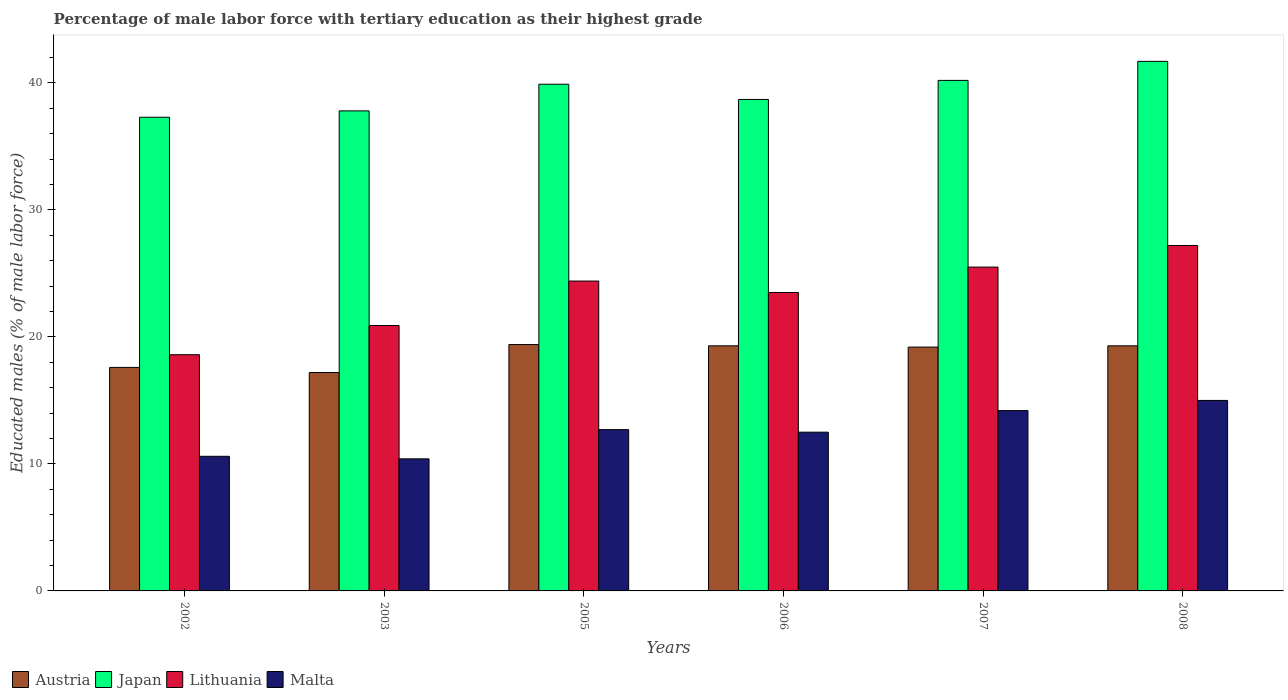How many different coloured bars are there?
Keep it short and to the point. 4. How many groups of bars are there?
Your response must be concise. 6. How many bars are there on the 3rd tick from the right?
Keep it short and to the point. 4. What is the label of the 6th group of bars from the left?
Make the answer very short. 2008. What is the percentage of male labor force with tertiary education in Japan in 2002?
Your answer should be compact. 37.3. Across all years, what is the maximum percentage of male labor force with tertiary education in Japan?
Offer a terse response. 41.7. Across all years, what is the minimum percentage of male labor force with tertiary education in Austria?
Your response must be concise. 17.2. In which year was the percentage of male labor force with tertiary education in Lithuania maximum?
Offer a very short reply. 2008. In which year was the percentage of male labor force with tertiary education in Japan minimum?
Your answer should be compact. 2002. What is the total percentage of male labor force with tertiary education in Austria in the graph?
Offer a terse response. 112. What is the difference between the percentage of male labor force with tertiary education in Lithuania in 2003 and that in 2008?
Your response must be concise. -6.3. What is the difference between the percentage of male labor force with tertiary education in Malta in 2008 and the percentage of male labor force with tertiary education in Austria in 2005?
Give a very brief answer. -4.4. What is the average percentage of male labor force with tertiary education in Malta per year?
Offer a terse response. 12.57. In the year 2003, what is the difference between the percentage of male labor force with tertiary education in Japan and percentage of male labor force with tertiary education in Malta?
Keep it short and to the point. 27.4. In how many years, is the percentage of male labor force with tertiary education in Malta greater than 32 %?
Offer a terse response. 0. What is the ratio of the percentage of male labor force with tertiary education in Lithuania in 2003 to that in 2007?
Keep it short and to the point. 0.82. Is the percentage of male labor force with tertiary education in Austria in 2005 less than that in 2007?
Keep it short and to the point. No. Is the difference between the percentage of male labor force with tertiary education in Japan in 2002 and 2008 greater than the difference between the percentage of male labor force with tertiary education in Malta in 2002 and 2008?
Your answer should be compact. No. What is the difference between the highest and the second highest percentage of male labor force with tertiary education in Austria?
Your answer should be compact. 0.1. What is the difference between the highest and the lowest percentage of male labor force with tertiary education in Japan?
Your answer should be compact. 4.4. In how many years, is the percentage of male labor force with tertiary education in Malta greater than the average percentage of male labor force with tertiary education in Malta taken over all years?
Make the answer very short. 3. Is the sum of the percentage of male labor force with tertiary education in Malta in 2002 and 2007 greater than the maximum percentage of male labor force with tertiary education in Japan across all years?
Give a very brief answer. No. What does the 3rd bar from the left in 2002 represents?
Offer a very short reply. Lithuania. Is it the case that in every year, the sum of the percentage of male labor force with tertiary education in Austria and percentage of male labor force with tertiary education in Japan is greater than the percentage of male labor force with tertiary education in Malta?
Give a very brief answer. Yes. Are the values on the major ticks of Y-axis written in scientific E-notation?
Your response must be concise. No. Does the graph contain any zero values?
Provide a short and direct response. No. What is the title of the graph?
Ensure brevity in your answer.  Percentage of male labor force with tertiary education as their highest grade. What is the label or title of the X-axis?
Offer a very short reply. Years. What is the label or title of the Y-axis?
Ensure brevity in your answer.  Educated males (% of male labor force). What is the Educated males (% of male labor force) in Austria in 2002?
Your response must be concise. 17.6. What is the Educated males (% of male labor force) in Japan in 2002?
Offer a very short reply. 37.3. What is the Educated males (% of male labor force) in Lithuania in 2002?
Ensure brevity in your answer.  18.6. What is the Educated males (% of male labor force) in Malta in 2002?
Your answer should be compact. 10.6. What is the Educated males (% of male labor force) of Austria in 2003?
Your answer should be very brief. 17.2. What is the Educated males (% of male labor force) of Japan in 2003?
Give a very brief answer. 37.8. What is the Educated males (% of male labor force) of Lithuania in 2003?
Keep it short and to the point. 20.9. What is the Educated males (% of male labor force) in Malta in 2003?
Your response must be concise. 10.4. What is the Educated males (% of male labor force) of Austria in 2005?
Give a very brief answer. 19.4. What is the Educated males (% of male labor force) of Japan in 2005?
Provide a succinct answer. 39.9. What is the Educated males (% of male labor force) of Lithuania in 2005?
Give a very brief answer. 24.4. What is the Educated males (% of male labor force) of Malta in 2005?
Your answer should be compact. 12.7. What is the Educated males (% of male labor force) of Austria in 2006?
Provide a short and direct response. 19.3. What is the Educated males (% of male labor force) in Japan in 2006?
Offer a very short reply. 38.7. What is the Educated males (% of male labor force) in Austria in 2007?
Your answer should be compact. 19.2. What is the Educated males (% of male labor force) in Japan in 2007?
Provide a succinct answer. 40.2. What is the Educated males (% of male labor force) of Malta in 2007?
Provide a succinct answer. 14.2. What is the Educated males (% of male labor force) in Austria in 2008?
Ensure brevity in your answer.  19.3. What is the Educated males (% of male labor force) in Japan in 2008?
Ensure brevity in your answer.  41.7. What is the Educated males (% of male labor force) in Lithuania in 2008?
Provide a short and direct response. 27.2. Across all years, what is the maximum Educated males (% of male labor force) of Austria?
Ensure brevity in your answer.  19.4. Across all years, what is the maximum Educated males (% of male labor force) of Japan?
Offer a terse response. 41.7. Across all years, what is the maximum Educated males (% of male labor force) in Lithuania?
Provide a short and direct response. 27.2. Across all years, what is the maximum Educated males (% of male labor force) in Malta?
Keep it short and to the point. 15. Across all years, what is the minimum Educated males (% of male labor force) in Austria?
Your answer should be compact. 17.2. Across all years, what is the minimum Educated males (% of male labor force) of Japan?
Provide a succinct answer. 37.3. Across all years, what is the minimum Educated males (% of male labor force) of Lithuania?
Ensure brevity in your answer.  18.6. Across all years, what is the minimum Educated males (% of male labor force) of Malta?
Offer a terse response. 10.4. What is the total Educated males (% of male labor force) in Austria in the graph?
Keep it short and to the point. 112. What is the total Educated males (% of male labor force) in Japan in the graph?
Ensure brevity in your answer.  235.6. What is the total Educated males (% of male labor force) in Lithuania in the graph?
Your answer should be compact. 140.1. What is the total Educated males (% of male labor force) of Malta in the graph?
Provide a succinct answer. 75.4. What is the difference between the Educated males (% of male labor force) of Japan in 2002 and that in 2003?
Provide a short and direct response. -0.5. What is the difference between the Educated males (% of male labor force) of Malta in 2002 and that in 2003?
Make the answer very short. 0.2. What is the difference between the Educated males (% of male labor force) of Austria in 2002 and that in 2005?
Ensure brevity in your answer.  -1.8. What is the difference between the Educated males (% of male labor force) in Japan in 2002 and that in 2005?
Keep it short and to the point. -2.6. What is the difference between the Educated males (% of male labor force) of Lithuania in 2002 and that in 2005?
Your answer should be very brief. -5.8. What is the difference between the Educated males (% of male labor force) in Malta in 2002 and that in 2005?
Your response must be concise. -2.1. What is the difference between the Educated males (% of male labor force) in Austria in 2002 and that in 2006?
Give a very brief answer. -1.7. What is the difference between the Educated males (% of male labor force) of Japan in 2002 and that in 2006?
Offer a terse response. -1.4. What is the difference between the Educated males (% of male labor force) of Lithuania in 2002 and that in 2006?
Your answer should be compact. -4.9. What is the difference between the Educated males (% of male labor force) of Malta in 2002 and that in 2006?
Provide a succinct answer. -1.9. What is the difference between the Educated males (% of male labor force) in Malta in 2002 and that in 2007?
Keep it short and to the point. -3.6. What is the difference between the Educated males (% of male labor force) in Austria in 2002 and that in 2008?
Your response must be concise. -1.7. What is the difference between the Educated males (% of male labor force) of Malta in 2002 and that in 2008?
Give a very brief answer. -4.4. What is the difference between the Educated males (% of male labor force) in Austria in 2003 and that in 2005?
Offer a terse response. -2.2. What is the difference between the Educated males (% of male labor force) of Japan in 2003 and that in 2005?
Make the answer very short. -2.1. What is the difference between the Educated males (% of male labor force) in Lithuania in 2003 and that in 2005?
Your response must be concise. -3.5. What is the difference between the Educated males (% of male labor force) in Austria in 2003 and that in 2006?
Give a very brief answer. -2.1. What is the difference between the Educated males (% of male labor force) in Japan in 2003 and that in 2006?
Your answer should be compact. -0.9. What is the difference between the Educated males (% of male labor force) of Lithuania in 2003 and that in 2006?
Your response must be concise. -2.6. What is the difference between the Educated males (% of male labor force) of Austria in 2003 and that in 2007?
Your answer should be compact. -2. What is the difference between the Educated males (% of male labor force) of Malta in 2003 and that in 2007?
Offer a very short reply. -3.8. What is the difference between the Educated males (% of male labor force) of Lithuania in 2003 and that in 2008?
Give a very brief answer. -6.3. What is the difference between the Educated males (% of male labor force) of Malta in 2003 and that in 2008?
Make the answer very short. -4.6. What is the difference between the Educated males (% of male labor force) in Lithuania in 2005 and that in 2006?
Ensure brevity in your answer.  0.9. What is the difference between the Educated males (% of male labor force) in Malta in 2005 and that in 2007?
Make the answer very short. -1.5. What is the difference between the Educated males (% of male labor force) in Austria in 2005 and that in 2008?
Keep it short and to the point. 0.1. What is the difference between the Educated males (% of male labor force) in Japan in 2005 and that in 2008?
Offer a terse response. -1.8. What is the difference between the Educated males (% of male labor force) in Malta in 2005 and that in 2008?
Ensure brevity in your answer.  -2.3. What is the difference between the Educated males (% of male labor force) in Malta in 2006 and that in 2007?
Offer a terse response. -1.7. What is the difference between the Educated males (% of male labor force) in Japan in 2006 and that in 2008?
Keep it short and to the point. -3. What is the difference between the Educated males (% of male labor force) of Malta in 2006 and that in 2008?
Offer a terse response. -2.5. What is the difference between the Educated males (% of male labor force) in Lithuania in 2007 and that in 2008?
Keep it short and to the point. -1.7. What is the difference between the Educated males (% of male labor force) of Malta in 2007 and that in 2008?
Provide a succinct answer. -0.8. What is the difference between the Educated males (% of male labor force) in Austria in 2002 and the Educated males (% of male labor force) in Japan in 2003?
Your response must be concise. -20.2. What is the difference between the Educated males (% of male labor force) of Austria in 2002 and the Educated males (% of male labor force) of Lithuania in 2003?
Provide a succinct answer. -3.3. What is the difference between the Educated males (% of male labor force) of Austria in 2002 and the Educated males (% of male labor force) of Malta in 2003?
Provide a short and direct response. 7.2. What is the difference between the Educated males (% of male labor force) in Japan in 2002 and the Educated males (% of male labor force) in Malta in 2003?
Ensure brevity in your answer.  26.9. What is the difference between the Educated males (% of male labor force) in Lithuania in 2002 and the Educated males (% of male labor force) in Malta in 2003?
Make the answer very short. 8.2. What is the difference between the Educated males (% of male labor force) of Austria in 2002 and the Educated males (% of male labor force) of Japan in 2005?
Keep it short and to the point. -22.3. What is the difference between the Educated males (% of male labor force) of Austria in 2002 and the Educated males (% of male labor force) of Lithuania in 2005?
Offer a terse response. -6.8. What is the difference between the Educated males (% of male labor force) of Austria in 2002 and the Educated males (% of male labor force) of Malta in 2005?
Provide a short and direct response. 4.9. What is the difference between the Educated males (% of male labor force) in Japan in 2002 and the Educated males (% of male labor force) in Lithuania in 2005?
Give a very brief answer. 12.9. What is the difference between the Educated males (% of male labor force) of Japan in 2002 and the Educated males (% of male labor force) of Malta in 2005?
Keep it short and to the point. 24.6. What is the difference between the Educated males (% of male labor force) in Austria in 2002 and the Educated males (% of male labor force) in Japan in 2006?
Ensure brevity in your answer.  -21.1. What is the difference between the Educated males (% of male labor force) of Austria in 2002 and the Educated males (% of male labor force) of Lithuania in 2006?
Offer a very short reply. -5.9. What is the difference between the Educated males (% of male labor force) of Austria in 2002 and the Educated males (% of male labor force) of Malta in 2006?
Your response must be concise. 5.1. What is the difference between the Educated males (% of male labor force) of Japan in 2002 and the Educated males (% of male labor force) of Lithuania in 2006?
Your answer should be compact. 13.8. What is the difference between the Educated males (% of male labor force) in Japan in 2002 and the Educated males (% of male labor force) in Malta in 2006?
Your answer should be compact. 24.8. What is the difference between the Educated males (% of male labor force) in Lithuania in 2002 and the Educated males (% of male labor force) in Malta in 2006?
Ensure brevity in your answer.  6.1. What is the difference between the Educated males (% of male labor force) in Austria in 2002 and the Educated males (% of male labor force) in Japan in 2007?
Your response must be concise. -22.6. What is the difference between the Educated males (% of male labor force) of Austria in 2002 and the Educated males (% of male labor force) of Lithuania in 2007?
Offer a terse response. -7.9. What is the difference between the Educated males (% of male labor force) in Japan in 2002 and the Educated males (% of male labor force) in Lithuania in 2007?
Offer a very short reply. 11.8. What is the difference between the Educated males (% of male labor force) in Japan in 2002 and the Educated males (% of male labor force) in Malta in 2007?
Provide a succinct answer. 23.1. What is the difference between the Educated males (% of male labor force) of Lithuania in 2002 and the Educated males (% of male labor force) of Malta in 2007?
Ensure brevity in your answer.  4.4. What is the difference between the Educated males (% of male labor force) of Austria in 2002 and the Educated males (% of male labor force) of Japan in 2008?
Make the answer very short. -24.1. What is the difference between the Educated males (% of male labor force) in Austria in 2002 and the Educated males (% of male labor force) in Lithuania in 2008?
Make the answer very short. -9.6. What is the difference between the Educated males (% of male labor force) of Austria in 2002 and the Educated males (% of male labor force) of Malta in 2008?
Your answer should be very brief. 2.6. What is the difference between the Educated males (% of male labor force) in Japan in 2002 and the Educated males (% of male labor force) in Lithuania in 2008?
Make the answer very short. 10.1. What is the difference between the Educated males (% of male labor force) of Japan in 2002 and the Educated males (% of male labor force) of Malta in 2008?
Your response must be concise. 22.3. What is the difference between the Educated males (% of male labor force) of Austria in 2003 and the Educated males (% of male labor force) of Japan in 2005?
Provide a short and direct response. -22.7. What is the difference between the Educated males (% of male labor force) of Austria in 2003 and the Educated males (% of male labor force) of Malta in 2005?
Your answer should be very brief. 4.5. What is the difference between the Educated males (% of male labor force) in Japan in 2003 and the Educated males (% of male labor force) in Malta in 2005?
Give a very brief answer. 25.1. What is the difference between the Educated males (% of male labor force) of Lithuania in 2003 and the Educated males (% of male labor force) of Malta in 2005?
Your response must be concise. 8.2. What is the difference between the Educated males (% of male labor force) in Austria in 2003 and the Educated males (% of male labor force) in Japan in 2006?
Keep it short and to the point. -21.5. What is the difference between the Educated males (% of male labor force) in Japan in 2003 and the Educated males (% of male labor force) in Lithuania in 2006?
Your answer should be very brief. 14.3. What is the difference between the Educated males (% of male labor force) in Japan in 2003 and the Educated males (% of male labor force) in Malta in 2006?
Ensure brevity in your answer.  25.3. What is the difference between the Educated males (% of male labor force) in Lithuania in 2003 and the Educated males (% of male labor force) in Malta in 2006?
Offer a very short reply. 8.4. What is the difference between the Educated males (% of male labor force) in Austria in 2003 and the Educated males (% of male labor force) in Japan in 2007?
Ensure brevity in your answer.  -23. What is the difference between the Educated males (% of male labor force) of Austria in 2003 and the Educated males (% of male labor force) of Lithuania in 2007?
Offer a terse response. -8.3. What is the difference between the Educated males (% of male labor force) of Austria in 2003 and the Educated males (% of male labor force) of Malta in 2007?
Your response must be concise. 3. What is the difference between the Educated males (% of male labor force) in Japan in 2003 and the Educated males (% of male labor force) in Lithuania in 2007?
Ensure brevity in your answer.  12.3. What is the difference between the Educated males (% of male labor force) in Japan in 2003 and the Educated males (% of male labor force) in Malta in 2007?
Your answer should be very brief. 23.6. What is the difference between the Educated males (% of male labor force) of Austria in 2003 and the Educated males (% of male labor force) of Japan in 2008?
Give a very brief answer. -24.5. What is the difference between the Educated males (% of male labor force) in Japan in 2003 and the Educated males (% of male labor force) in Malta in 2008?
Provide a succinct answer. 22.8. What is the difference between the Educated males (% of male labor force) of Lithuania in 2003 and the Educated males (% of male labor force) of Malta in 2008?
Provide a succinct answer. 5.9. What is the difference between the Educated males (% of male labor force) in Austria in 2005 and the Educated males (% of male labor force) in Japan in 2006?
Offer a very short reply. -19.3. What is the difference between the Educated males (% of male labor force) of Japan in 2005 and the Educated males (% of male labor force) of Lithuania in 2006?
Make the answer very short. 16.4. What is the difference between the Educated males (% of male labor force) in Japan in 2005 and the Educated males (% of male labor force) in Malta in 2006?
Offer a very short reply. 27.4. What is the difference between the Educated males (% of male labor force) in Austria in 2005 and the Educated males (% of male labor force) in Japan in 2007?
Ensure brevity in your answer.  -20.8. What is the difference between the Educated males (% of male labor force) in Austria in 2005 and the Educated males (% of male labor force) in Lithuania in 2007?
Provide a short and direct response. -6.1. What is the difference between the Educated males (% of male labor force) in Austria in 2005 and the Educated males (% of male labor force) in Malta in 2007?
Keep it short and to the point. 5.2. What is the difference between the Educated males (% of male labor force) of Japan in 2005 and the Educated males (% of male labor force) of Malta in 2007?
Provide a short and direct response. 25.7. What is the difference between the Educated males (% of male labor force) in Austria in 2005 and the Educated males (% of male labor force) in Japan in 2008?
Offer a very short reply. -22.3. What is the difference between the Educated males (% of male labor force) of Austria in 2005 and the Educated males (% of male labor force) of Lithuania in 2008?
Offer a very short reply. -7.8. What is the difference between the Educated males (% of male labor force) of Austria in 2005 and the Educated males (% of male labor force) of Malta in 2008?
Make the answer very short. 4.4. What is the difference between the Educated males (% of male labor force) in Japan in 2005 and the Educated males (% of male labor force) in Malta in 2008?
Offer a terse response. 24.9. What is the difference between the Educated males (% of male labor force) of Austria in 2006 and the Educated males (% of male labor force) of Japan in 2007?
Make the answer very short. -20.9. What is the difference between the Educated males (% of male labor force) in Austria in 2006 and the Educated males (% of male labor force) in Lithuania in 2007?
Offer a very short reply. -6.2. What is the difference between the Educated males (% of male labor force) of Japan in 2006 and the Educated males (% of male labor force) of Malta in 2007?
Provide a succinct answer. 24.5. What is the difference between the Educated males (% of male labor force) of Austria in 2006 and the Educated males (% of male labor force) of Japan in 2008?
Your answer should be compact. -22.4. What is the difference between the Educated males (% of male labor force) in Japan in 2006 and the Educated males (% of male labor force) in Malta in 2008?
Provide a short and direct response. 23.7. What is the difference between the Educated males (% of male labor force) in Austria in 2007 and the Educated males (% of male labor force) in Japan in 2008?
Provide a succinct answer. -22.5. What is the difference between the Educated males (% of male labor force) of Austria in 2007 and the Educated males (% of male labor force) of Lithuania in 2008?
Offer a terse response. -8. What is the difference between the Educated males (% of male labor force) in Austria in 2007 and the Educated males (% of male labor force) in Malta in 2008?
Your response must be concise. 4.2. What is the difference between the Educated males (% of male labor force) of Japan in 2007 and the Educated males (% of male labor force) of Malta in 2008?
Provide a succinct answer. 25.2. What is the difference between the Educated males (% of male labor force) in Lithuania in 2007 and the Educated males (% of male labor force) in Malta in 2008?
Your answer should be very brief. 10.5. What is the average Educated males (% of male labor force) in Austria per year?
Give a very brief answer. 18.67. What is the average Educated males (% of male labor force) in Japan per year?
Offer a very short reply. 39.27. What is the average Educated males (% of male labor force) of Lithuania per year?
Offer a terse response. 23.35. What is the average Educated males (% of male labor force) in Malta per year?
Give a very brief answer. 12.57. In the year 2002, what is the difference between the Educated males (% of male labor force) in Austria and Educated males (% of male labor force) in Japan?
Your response must be concise. -19.7. In the year 2002, what is the difference between the Educated males (% of male labor force) of Austria and Educated males (% of male labor force) of Lithuania?
Make the answer very short. -1. In the year 2002, what is the difference between the Educated males (% of male labor force) of Austria and Educated males (% of male labor force) of Malta?
Ensure brevity in your answer.  7. In the year 2002, what is the difference between the Educated males (% of male labor force) in Japan and Educated males (% of male labor force) in Lithuania?
Keep it short and to the point. 18.7. In the year 2002, what is the difference between the Educated males (% of male labor force) in Japan and Educated males (% of male labor force) in Malta?
Offer a very short reply. 26.7. In the year 2003, what is the difference between the Educated males (% of male labor force) in Austria and Educated males (% of male labor force) in Japan?
Offer a very short reply. -20.6. In the year 2003, what is the difference between the Educated males (% of male labor force) in Austria and Educated males (% of male labor force) in Lithuania?
Provide a succinct answer. -3.7. In the year 2003, what is the difference between the Educated males (% of male labor force) in Austria and Educated males (% of male labor force) in Malta?
Your response must be concise. 6.8. In the year 2003, what is the difference between the Educated males (% of male labor force) of Japan and Educated males (% of male labor force) of Malta?
Your answer should be compact. 27.4. In the year 2003, what is the difference between the Educated males (% of male labor force) of Lithuania and Educated males (% of male labor force) of Malta?
Your answer should be compact. 10.5. In the year 2005, what is the difference between the Educated males (% of male labor force) of Austria and Educated males (% of male labor force) of Japan?
Ensure brevity in your answer.  -20.5. In the year 2005, what is the difference between the Educated males (% of male labor force) of Austria and Educated males (% of male labor force) of Malta?
Keep it short and to the point. 6.7. In the year 2005, what is the difference between the Educated males (% of male labor force) in Japan and Educated males (% of male labor force) in Malta?
Your response must be concise. 27.2. In the year 2006, what is the difference between the Educated males (% of male labor force) of Austria and Educated males (% of male labor force) of Japan?
Your response must be concise. -19.4. In the year 2006, what is the difference between the Educated males (% of male labor force) in Austria and Educated males (% of male labor force) in Lithuania?
Give a very brief answer. -4.2. In the year 2006, what is the difference between the Educated males (% of male labor force) in Japan and Educated males (% of male labor force) in Malta?
Your answer should be compact. 26.2. In the year 2006, what is the difference between the Educated males (% of male labor force) of Lithuania and Educated males (% of male labor force) of Malta?
Make the answer very short. 11. In the year 2007, what is the difference between the Educated males (% of male labor force) in Austria and Educated males (% of male labor force) in Japan?
Your response must be concise. -21. In the year 2007, what is the difference between the Educated males (% of male labor force) in Austria and Educated males (% of male labor force) in Lithuania?
Provide a short and direct response. -6.3. In the year 2007, what is the difference between the Educated males (% of male labor force) in Austria and Educated males (% of male labor force) in Malta?
Keep it short and to the point. 5. In the year 2007, what is the difference between the Educated males (% of male labor force) of Lithuania and Educated males (% of male labor force) of Malta?
Make the answer very short. 11.3. In the year 2008, what is the difference between the Educated males (% of male labor force) of Austria and Educated males (% of male labor force) of Japan?
Your answer should be compact. -22.4. In the year 2008, what is the difference between the Educated males (% of male labor force) of Austria and Educated males (% of male labor force) of Lithuania?
Your response must be concise. -7.9. In the year 2008, what is the difference between the Educated males (% of male labor force) in Japan and Educated males (% of male labor force) in Malta?
Your answer should be very brief. 26.7. In the year 2008, what is the difference between the Educated males (% of male labor force) of Lithuania and Educated males (% of male labor force) of Malta?
Provide a succinct answer. 12.2. What is the ratio of the Educated males (% of male labor force) of Austria in 2002 to that in 2003?
Your answer should be compact. 1.02. What is the ratio of the Educated males (% of male labor force) of Japan in 2002 to that in 2003?
Provide a succinct answer. 0.99. What is the ratio of the Educated males (% of male labor force) of Lithuania in 2002 to that in 2003?
Your response must be concise. 0.89. What is the ratio of the Educated males (% of male labor force) of Malta in 2002 to that in 2003?
Your response must be concise. 1.02. What is the ratio of the Educated males (% of male labor force) of Austria in 2002 to that in 2005?
Offer a very short reply. 0.91. What is the ratio of the Educated males (% of male labor force) in Japan in 2002 to that in 2005?
Offer a terse response. 0.93. What is the ratio of the Educated males (% of male labor force) in Lithuania in 2002 to that in 2005?
Keep it short and to the point. 0.76. What is the ratio of the Educated males (% of male labor force) of Malta in 2002 to that in 2005?
Ensure brevity in your answer.  0.83. What is the ratio of the Educated males (% of male labor force) of Austria in 2002 to that in 2006?
Offer a terse response. 0.91. What is the ratio of the Educated males (% of male labor force) in Japan in 2002 to that in 2006?
Offer a very short reply. 0.96. What is the ratio of the Educated males (% of male labor force) of Lithuania in 2002 to that in 2006?
Offer a very short reply. 0.79. What is the ratio of the Educated males (% of male labor force) of Malta in 2002 to that in 2006?
Your answer should be very brief. 0.85. What is the ratio of the Educated males (% of male labor force) in Austria in 2002 to that in 2007?
Make the answer very short. 0.92. What is the ratio of the Educated males (% of male labor force) in Japan in 2002 to that in 2007?
Make the answer very short. 0.93. What is the ratio of the Educated males (% of male labor force) in Lithuania in 2002 to that in 2007?
Ensure brevity in your answer.  0.73. What is the ratio of the Educated males (% of male labor force) in Malta in 2002 to that in 2007?
Your answer should be very brief. 0.75. What is the ratio of the Educated males (% of male labor force) in Austria in 2002 to that in 2008?
Your answer should be very brief. 0.91. What is the ratio of the Educated males (% of male labor force) in Japan in 2002 to that in 2008?
Provide a succinct answer. 0.89. What is the ratio of the Educated males (% of male labor force) in Lithuania in 2002 to that in 2008?
Provide a short and direct response. 0.68. What is the ratio of the Educated males (% of male labor force) of Malta in 2002 to that in 2008?
Offer a terse response. 0.71. What is the ratio of the Educated males (% of male labor force) of Austria in 2003 to that in 2005?
Give a very brief answer. 0.89. What is the ratio of the Educated males (% of male labor force) in Japan in 2003 to that in 2005?
Your answer should be compact. 0.95. What is the ratio of the Educated males (% of male labor force) in Lithuania in 2003 to that in 2005?
Your answer should be compact. 0.86. What is the ratio of the Educated males (% of male labor force) in Malta in 2003 to that in 2005?
Ensure brevity in your answer.  0.82. What is the ratio of the Educated males (% of male labor force) in Austria in 2003 to that in 2006?
Your response must be concise. 0.89. What is the ratio of the Educated males (% of male labor force) of Japan in 2003 to that in 2006?
Provide a short and direct response. 0.98. What is the ratio of the Educated males (% of male labor force) of Lithuania in 2003 to that in 2006?
Offer a very short reply. 0.89. What is the ratio of the Educated males (% of male labor force) of Malta in 2003 to that in 2006?
Provide a succinct answer. 0.83. What is the ratio of the Educated males (% of male labor force) in Austria in 2003 to that in 2007?
Offer a very short reply. 0.9. What is the ratio of the Educated males (% of male labor force) of Japan in 2003 to that in 2007?
Provide a short and direct response. 0.94. What is the ratio of the Educated males (% of male labor force) of Lithuania in 2003 to that in 2007?
Provide a short and direct response. 0.82. What is the ratio of the Educated males (% of male labor force) in Malta in 2003 to that in 2007?
Your answer should be very brief. 0.73. What is the ratio of the Educated males (% of male labor force) in Austria in 2003 to that in 2008?
Keep it short and to the point. 0.89. What is the ratio of the Educated males (% of male labor force) of Japan in 2003 to that in 2008?
Provide a succinct answer. 0.91. What is the ratio of the Educated males (% of male labor force) in Lithuania in 2003 to that in 2008?
Provide a short and direct response. 0.77. What is the ratio of the Educated males (% of male labor force) in Malta in 2003 to that in 2008?
Your answer should be compact. 0.69. What is the ratio of the Educated males (% of male labor force) of Japan in 2005 to that in 2006?
Offer a very short reply. 1.03. What is the ratio of the Educated males (% of male labor force) in Lithuania in 2005 to that in 2006?
Give a very brief answer. 1.04. What is the ratio of the Educated males (% of male labor force) of Austria in 2005 to that in 2007?
Give a very brief answer. 1.01. What is the ratio of the Educated males (% of male labor force) of Lithuania in 2005 to that in 2007?
Keep it short and to the point. 0.96. What is the ratio of the Educated males (% of male labor force) in Malta in 2005 to that in 2007?
Provide a short and direct response. 0.89. What is the ratio of the Educated males (% of male labor force) in Japan in 2005 to that in 2008?
Ensure brevity in your answer.  0.96. What is the ratio of the Educated males (% of male labor force) in Lithuania in 2005 to that in 2008?
Give a very brief answer. 0.9. What is the ratio of the Educated males (% of male labor force) of Malta in 2005 to that in 2008?
Offer a very short reply. 0.85. What is the ratio of the Educated males (% of male labor force) of Japan in 2006 to that in 2007?
Give a very brief answer. 0.96. What is the ratio of the Educated males (% of male labor force) of Lithuania in 2006 to that in 2007?
Keep it short and to the point. 0.92. What is the ratio of the Educated males (% of male labor force) in Malta in 2006 to that in 2007?
Make the answer very short. 0.88. What is the ratio of the Educated males (% of male labor force) of Austria in 2006 to that in 2008?
Your response must be concise. 1. What is the ratio of the Educated males (% of male labor force) in Japan in 2006 to that in 2008?
Offer a terse response. 0.93. What is the ratio of the Educated males (% of male labor force) of Lithuania in 2006 to that in 2008?
Make the answer very short. 0.86. What is the ratio of the Educated males (% of male labor force) of Malta in 2006 to that in 2008?
Provide a succinct answer. 0.83. What is the ratio of the Educated males (% of male labor force) of Malta in 2007 to that in 2008?
Give a very brief answer. 0.95. What is the difference between the highest and the second highest Educated males (% of male labor force) in Japan?
Your answer should be compact. 1.5. What is the difference between the highest and the second highest Educated males (% of male labor force) in Malta?
Offer a terse response. 0.8. What is the difference between the highest and the lowest Educated males (% of male labor force) in Austria?
Offer a terse response. 2.2. What is the difference between the highest and the lowest Educated males (% of male labor force) of Lithuania?
Provide a short and direct response. 8.6. What is the difference between the highest and the lowest Educated males (% of male labor force) of Malta?
Give a very brief answer. 4.6. 